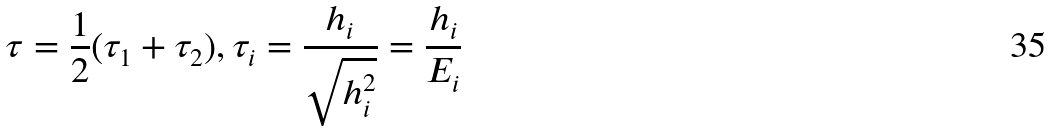<formula> <loc_0><loc_0><loc_500><loc_500>\tau = \frac { 1 } { 2 } ( \tau _ { 1 } + \tau _ { 2 } ) , \tau _ { i } = \frac { h _ { i } } { \sqrt { h _ { i } ^ { 2 } } } = \frac { h _ { i } } { E _ { i } }</formula> 